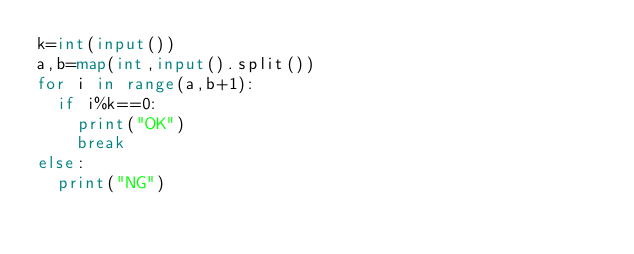Convert code to text. <code><loc_0><loc_0><loc_500><loc_500><_Python_>k=int(input())
a,b=map(int,input().split())
for i in range(a,b+1):
  if i%k==0:
    print("OK")
   	break
else:
  print("NG")</code> 